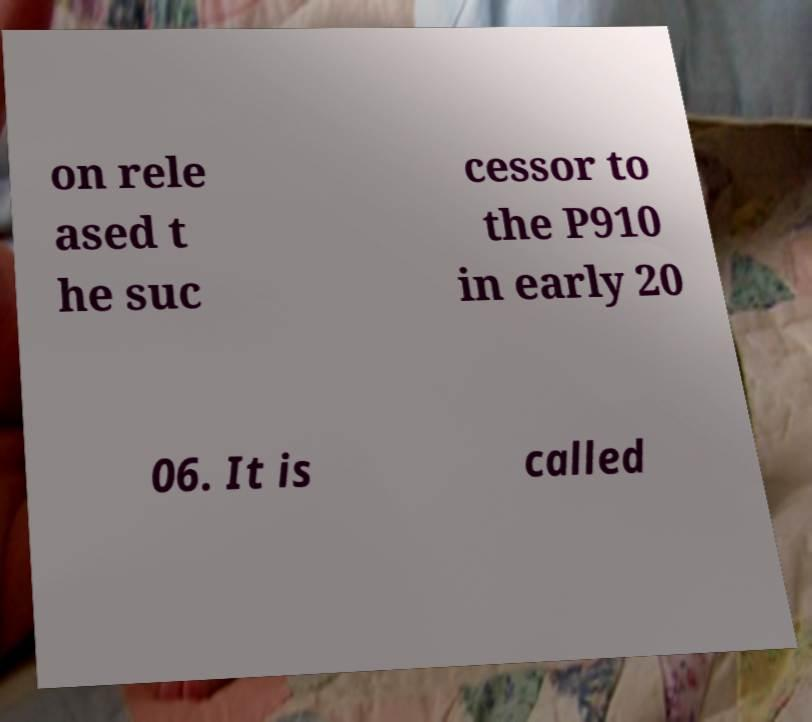Please read and relay the text visible in this image. What does it say? on rele ased t he suc cessor to the P910 in early 20 06. It is called 